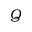<formula> <loc_0><loc_0><loc_500><loc_500>Q</formula> 